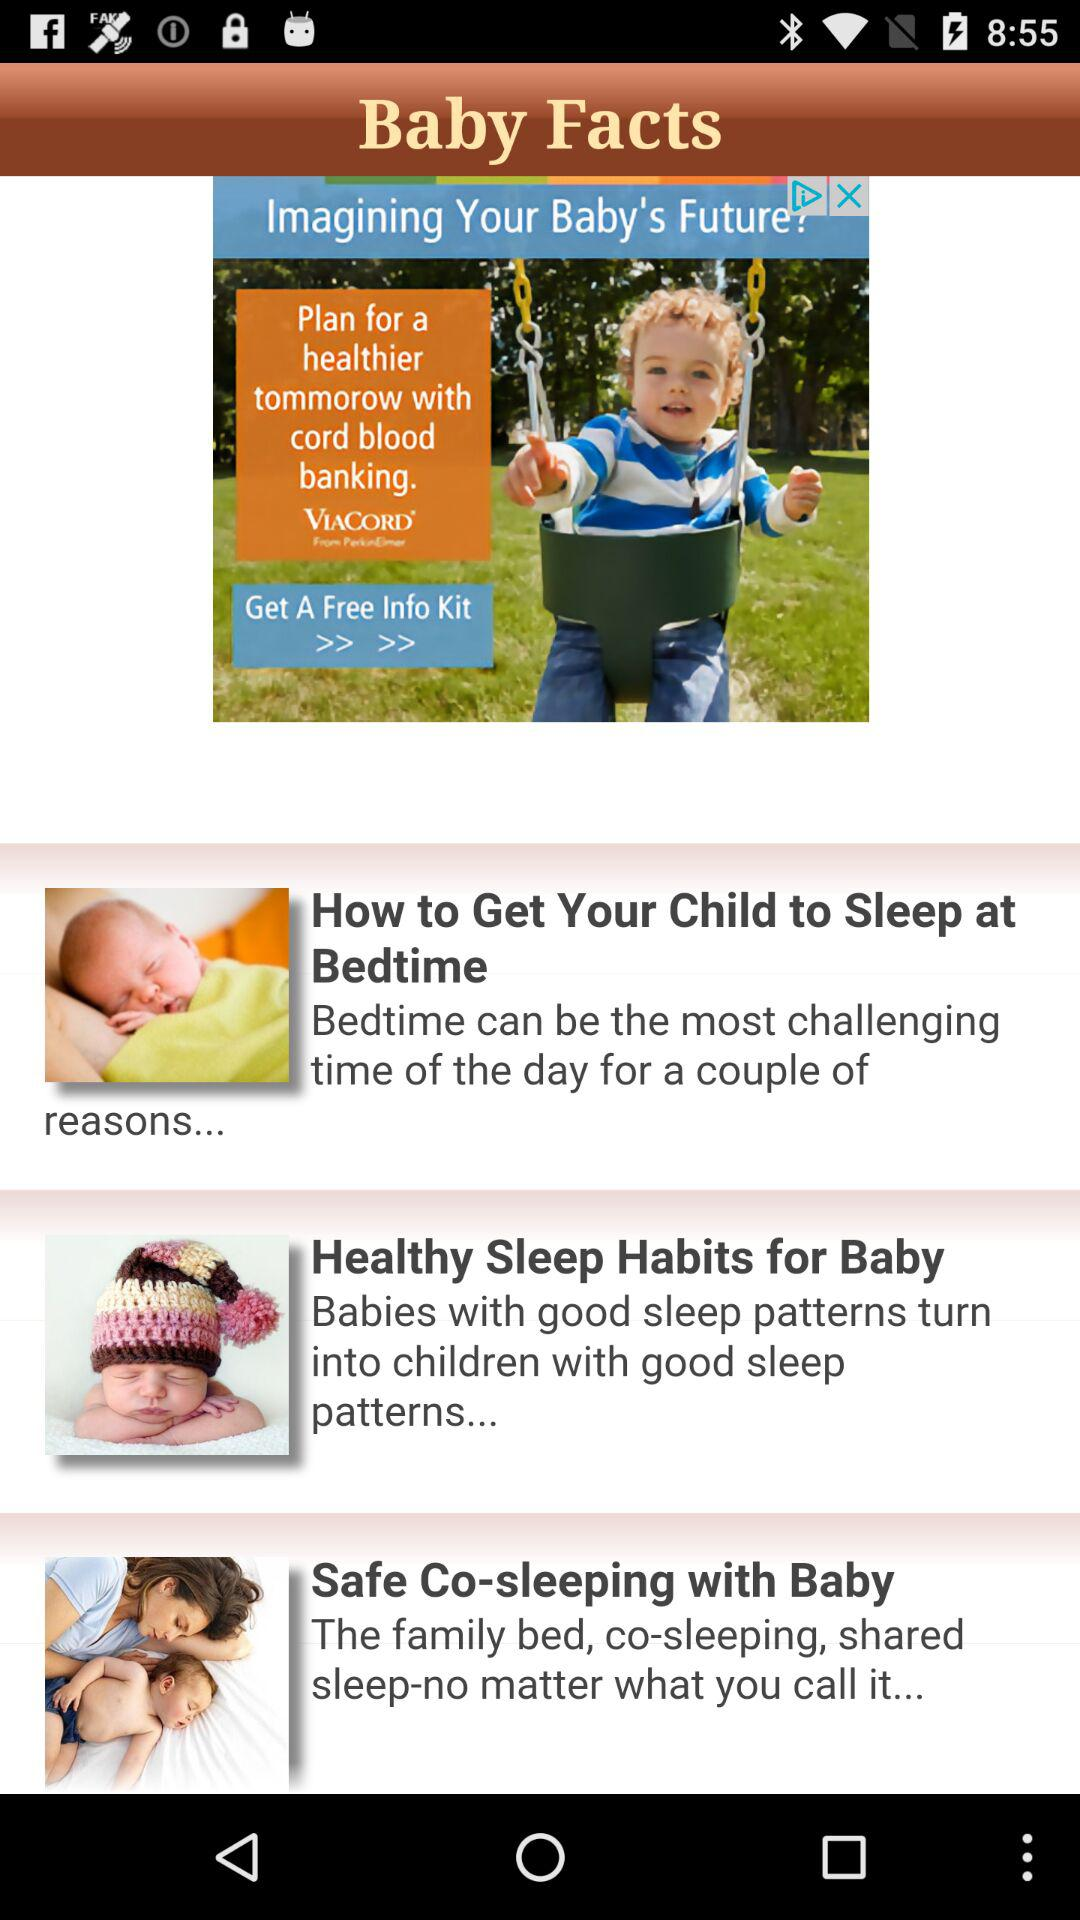How many items are under the header 'Baby Facts'?
Answer the question using a single word or phrase. 3 